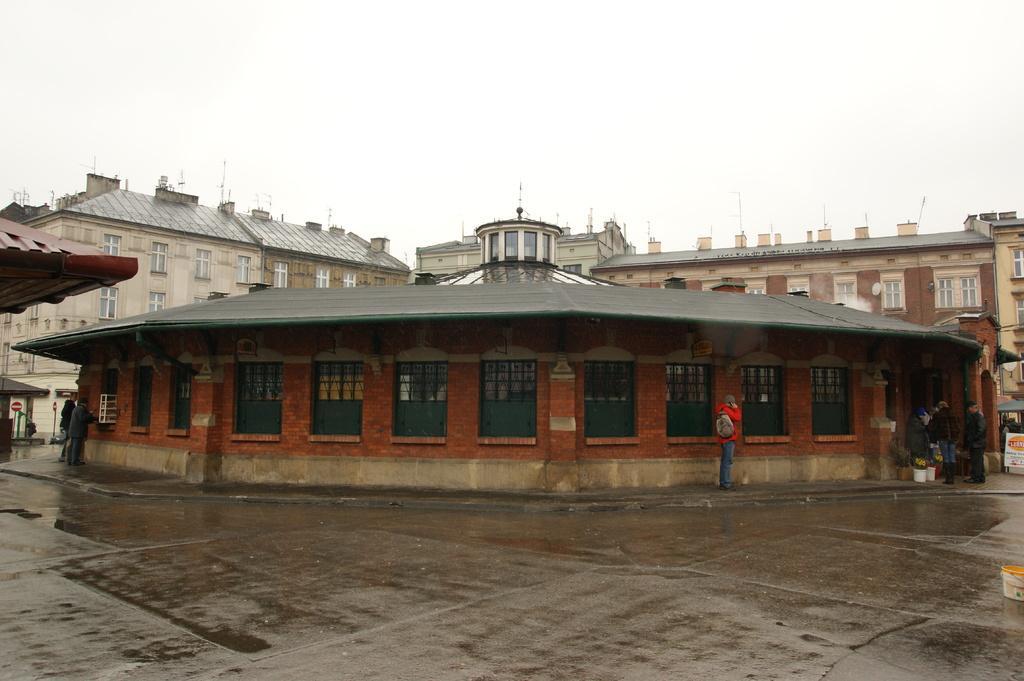How would you summarize this image in a sentence or two? In this image we can see some buildings with windows. We can also see the sign boards, some people standing on the ground and the sky. 